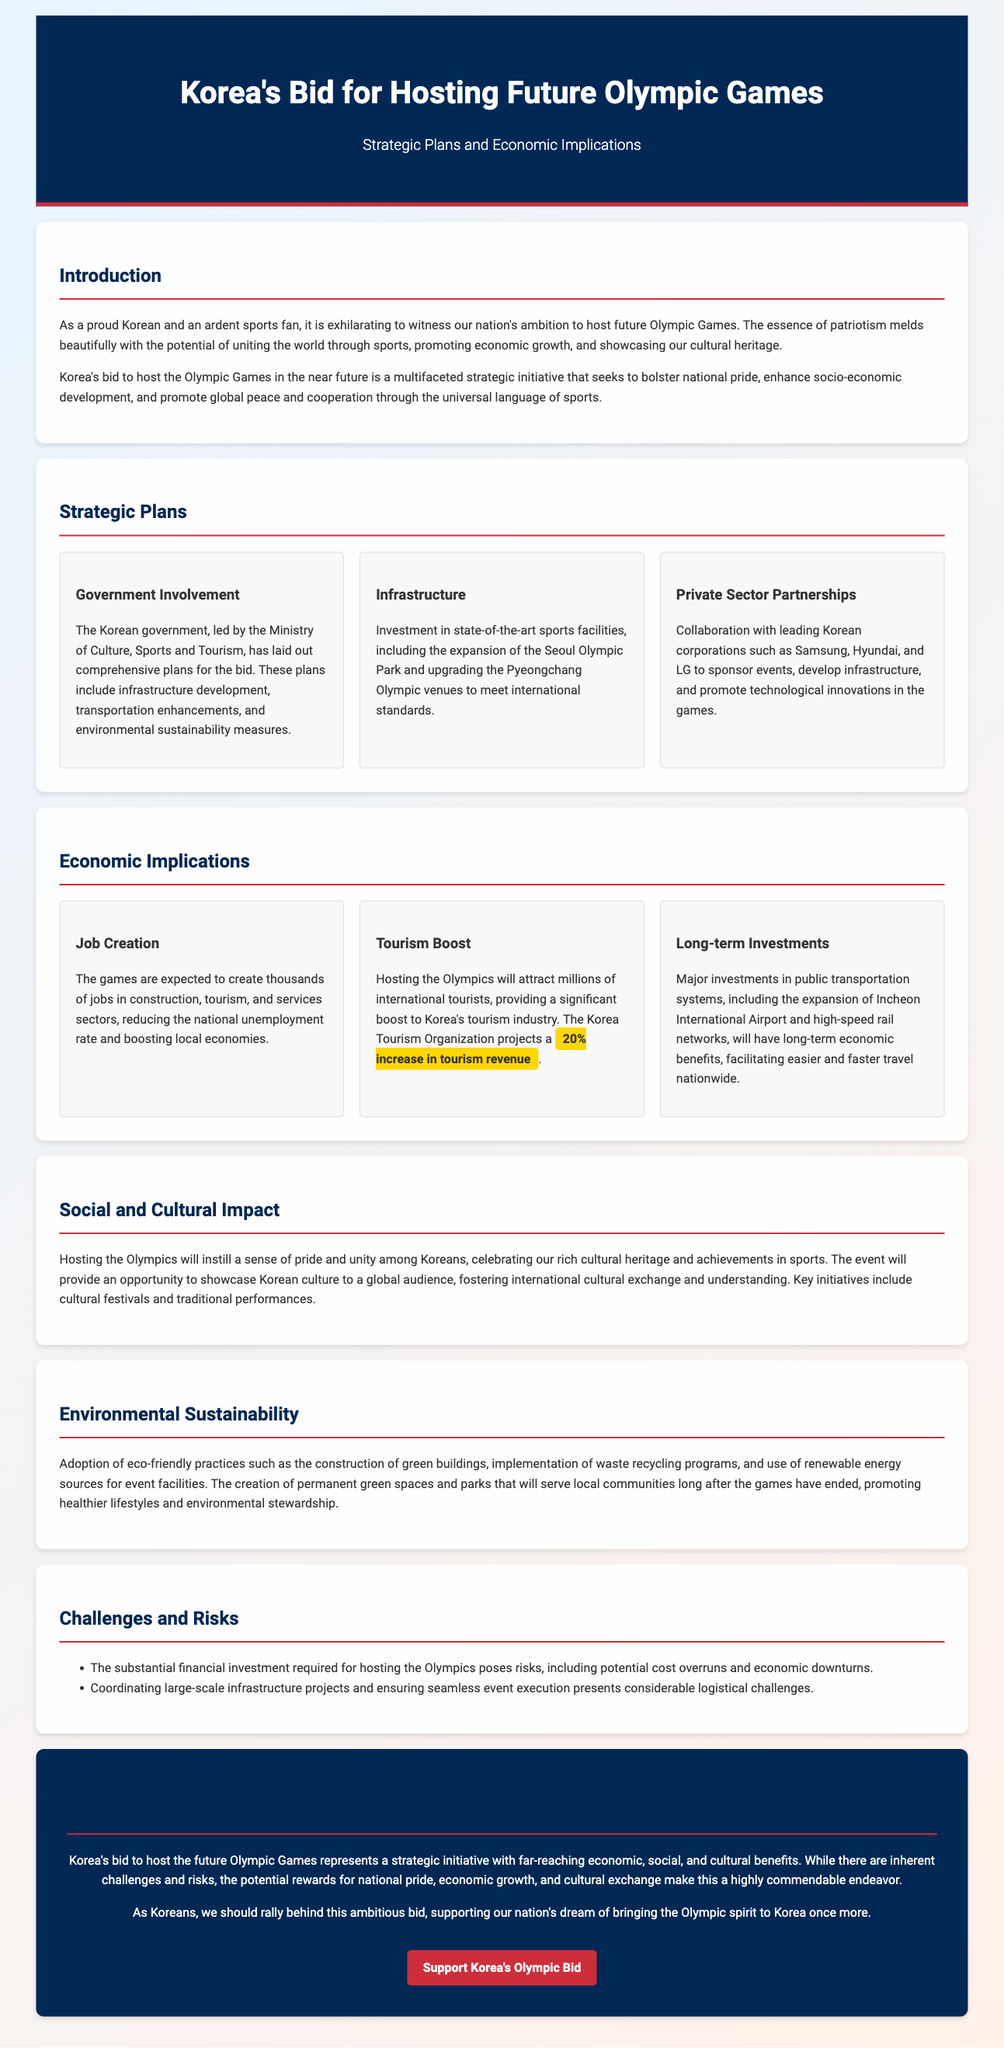What is the title of the document? The title reflects the main subject discussed in the whitepaper.
Answer: Korea's Bid for Hosting Future Olympic Games: Strategic Plans and Economic Implications Who leads the government involvement in the Olympic bid? This is mentioned in the section about government plans in the document.
Answer: Ministry of Culture, Sports and Tourism What is the projected increase in tourism revenue? This statistic is provided under the 'Tourism Boost' section of the document.
Answer: 20% What are the expected economic benefits of hosting the Olympics? The document outlines specific benefits related to job creation and long-term investments.
Answer: Job creation, tourism boost, long-term investments What is one of the challenges mentioned in the document? The document describes the challenges related to financing and execution.
Answer: Financial investment risks What kind of partnerships is emphasized in the strategic plans? This is detailed in the section about collaboration with corporations.
Answer: Private Sector Partnerships What initiative is mentioned to promote environmental sustainability? This is outlined in the section describing eco-friendly practices.
Answer: Construction of green buildings What is the conclusion's main message about the Olympic bid? This summarizes the overall sentiment towards the bid and its benefits.
Answer: A highly commendable endeavor 